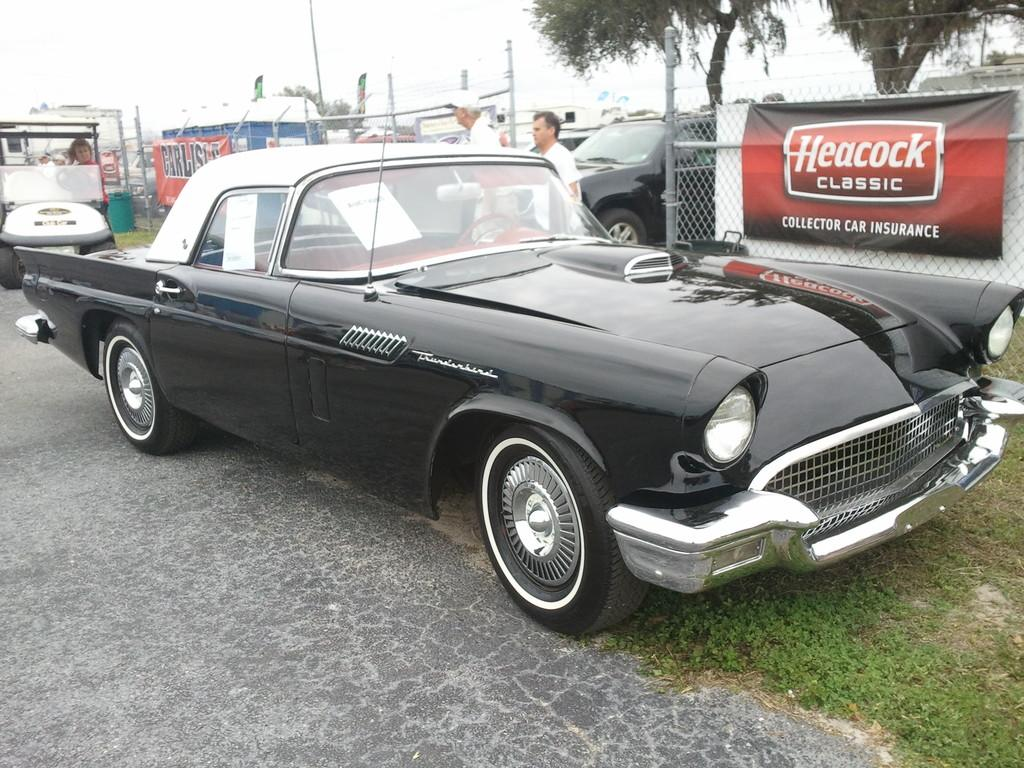What type of vehicle is in the front of the image? There is a black car in the front of the image. What can be seen on the fences in the image? There are banners on the fences in the image. How many other cars can be seen in the image? There are other cars visible in the image. What type of vegetation is on the right side of the image? There are trees on the right side of the image. What is visible at the top of the image? The sky is visible at the top of the image. How much sugar is in the black car in the image? There is no sugar present in the black car or the image; it is a vehicle. 